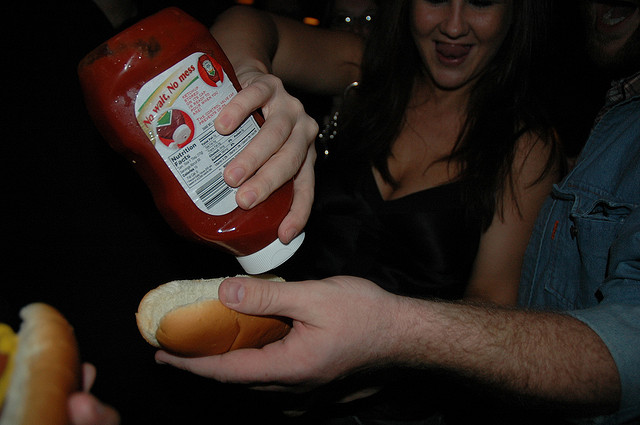<image>What letters are on the object being held? I am not sure what letters are on the object being held. It could be 'no wait no mess', 'ketchup', or 'k'. What letters are on the object being held? I don't know what letters are on the object being held. It can be seen 'no', 'no wait no mess', 'red', 'ketchup', 'none' or 'k'. 